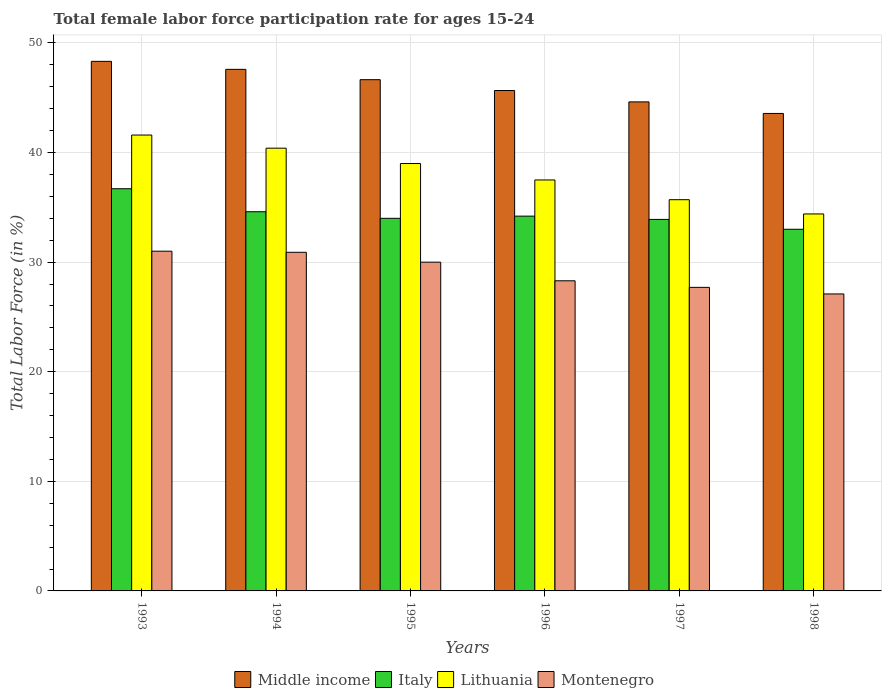How many bars are there on the 4th tick from the left?
Offer a terse response. 4. What is the label of the 4th group of bars from the left?
Give a very brief answer. 1996. In how many cases, is the number of bars for a given year not equal to the number of legend labels?
Ensure brevity in your answer.  0. What is the female labor force participation rate in Lithuania in 1994?
Offer a terse response. 40.4. Across all years, what is the maximum female labor force participation rate in Italy?
Give a very brief answer. 36.7. Across all years, what is the minimum female labor force participation rate in Italy?
Your response must be concise. 33. What is the total female labor force participation rate in Montenegro in the graph?
Your response must be concise. 175. What is the difference between the female labor force participation rate in Middle income in 1993 and that in 1997?
Your answer should be compact. 3.7. What is the average female labor force participation rate in Italy per year?
Your answer should be very brief. 34.4. In the year 1995, what is the difference between the female labor force participation rate in Lithuania and female labor force participation rate in Montenegro?
Offer a terse response. 9. What is the ratio of the female labor force participation rate in Lithuania in 1994 to that in 1995?
Make the answer very short. 1.04. Is the female labor force participation rate in Lithuania in 1994 less than that in 1997?
Your response must be concise. No. Is the difference between the female labor force participation rate in Lithuania in 1997 and 1998 greater than the difference between the female labor force participation rate in Montenegro in 1997 and 1998?
Provide a succinct answer. Yes. What is the difference between the highest and the second highest female labor force participation rate in Italy?
Your answer should be compact. 2.1. What is the difference between the highest and the lowest female labor force participation rate in Lithuania?
Provide a succinct answer. 7.2. In how many years, is the female labor force participation rate in Middle income greater than the average female labor force participation rate in Middle income taken over all years?
Offer a terse response. 3. Is it the case that in every year, the sum of the female labor force participation rate in Montenegro and female labor force participation rate in Middle income is greater than the sum of female labor force participation rate in Italy and female labor force participation rate in Lithuania?
Offer a terse response. Yes. What does the 3rd bar from the left in 1994 represents?
Your answer should be compact. Lithuania. What does the 4th bar from the right in 1998 represents?
Your response must be concise. Middle income. What is the title of the graph?
Keep it short and to the point. Total female labor force participation rate for ages 15-24. What is the Total Labor Force (in %) of Middle income in 1993?
Ensure brevity in your answer.  48.32. What is the Total Labor Force (in %) in Italy in 1993?
Provide a short and direct response. 36.7. What is the Total Labor Force (in %) of Lithuania in 1993?
Provide a short and direct response. 41.6. What is the Total Labor Force (in %) of Middle income in 1994?
Offer a very short reply. 47.59. What is the Total Labor Force (in %) in Italy in 1994?
Ensure brevity in your answer.  34.6. What is the Total Labor Force (in %) of Lithuania in 1994?
Offer a very short reply. 40.4. What is the Total Labor Force (in %) in Montenegro in 1994?
Make the answer very short. 30.9. What is the Total Labor Force (in %) in Middle income in 1995?
Offer a terse response. 46.65. What is the Total Labor Force (in %) of Montenegro in 1995?
Provide a succinct answer. 30. What is the Total Labor Force (in %) in Middle income in 1996?
Offer a terse response. 45.66. What is the Total Labor Force (in %) in Italy in 1996?
Give a very brief answer. 34.2. What is the Total Labor Force (in %) of Lithuania in 1996?
Offer a terse response. 37.5. What is the Total Labor Force (in %) of Montenegro in 1996?
Ensure brevity in your answer.  28.3. What is the Total Labor Force (in %) of Middle income in 1997?
Give a very brief answer. 44.62. What is the Total Labor Force (in %) of Italy in 1997?
Offer a terse response. 33.9. What is the Total Labor Force (in %) in Lithuania in 1997?
Keep it short and to the point. 35.7. What is the Total Labor Force (in %) in Montenegro in 1997?
Keep it short and to the point. 27.7. What is the Total Labor Force (in %) of Middle income in 1998?
Give a very brief answer. 43.57. What is the Total Labor Force (in %) of Lithuania in 1998?
Offer a terse response. 34.4. What is the Total Labor Force (in %) in Montenegro in 1998?
Your response must be concise. 27.1. Across all years, what is the maximum Total Labor Force (in %) in Middle income?
Make the answer very short. 48.32. Across all years, what is the maximum Total Labor Force (in %) in Italy?
Your answer should be very brief. 36.7. Across all years, what is the maximum Total Labor Force (in %) of Lithuania?
Your answer should be very brief. 41.6. Across all years, what is the maximum Total Labor Force (in %) of Montenegro?
Your answer should be very brief. 31. Across all years, what is the minimum Total Labor Force (in %) in Middle income?
Provide a succinct answer. 43.57. Across all years, what is the minimum Total Labor Force (in %) in Italy?
Ensure brevity in your answer.  33. Across all years, what is the minimum Total Labor Force (in %) of Lithuania?
Your answer should be compact. 34.4. Across all years, what is the minimum Total Labor Force (in %) in Montenegro?
Provide a succinct answer. 27.1. What is the total Total Labor Force (in %) of Middle income in the graph?
Provide a succinct answer. 276.42. What is the total Total Labor Force (in %) of Italy in the graph?
Your response must be concise. 206.4. What is the total Total Labor Force (in %) of Lithuania in the graph?
Provide a succinct answer. 228.6. What is the total Total Labor Force (in %) of Montenegro in the graph?
Your answer should be compact. 175. What is the difference between the Total Labor Force (in %) in Middle income in 1993 and that in 1994?
Provide a short and direct response. 0.73. What is the difference between the Total Labor Force (in %) in Italy in 1993 and that in 1994?
Offer a very short reply. 2.1. What is the difference between the Total Labor Force (in %) in Montenegro in 1993 and that in 1994?
Give a very brief answer. 0.1. What is the difference between the Total Labor Force (in %) of Middle income in 1993 and that in 1995?
Provide a short and direct response. 1.67. What is the difference between the Total Labor Force (in %) of Middle income in 1993 and that in 1996?
Provide a succinct answer. 2.66. What is the difference between the Total Labor Force (in %) in Italy in 1993 and that in 1996?
Make the answer very short. 2.5. What is the difference between the Total Labor Force (in %) in Lithuania in 1993 and that in 1996?
Offer a terse response. 4.1. What is the difference between the Total Labor Force (in %) in Montenegro in 1993 and that in 1996?
Offer a very short reply. 2.7. What is the difference between the Total Labor Force (in %) of Middle income in 1993 and that in 1997?
Your answer should be very brief. 3.7. What is the difference between the Total Labor Force (in %) of Italy in 1993 and that in 1997?
Keep it short and to the point. 2.8. What is the difference between the Total Labor Force (in %) of Middle income in 1993 and that in 1998?
Provide a short and direct response. 4.75. What is the difference between the Total Labor Force (in %) of Lithuania in 1993 and that in 1998?
Give a very brief answer. 7.2. What is the difference between the Total Labor Force (in %) in Middle income in 1994 and that in 1995?
Keep it short and to the point. 0.94. What is the difference between the Total Labor Force (in %) in Montenegro in 1994 and that in 1995?
Provide a short and direct response. 0.9. What is the difference between the Total Labor Force (in %) in Middle income in 1994 and that in 1996?
Offer a terse response. 1.93. What is the difference between the Total Labor Force (in %) in Italy in 1994 and that in 1996?
Make the answer very short. 0.4. What is the difference between the Total Labor Force (in %) in Lithuania in 1994 and that in 1996?
Your answer should be very brief. 2.9. What is the difference between the Total Labor Force (in %) of Middle income in 1994 and that in 1997?
Provide a succinct answer. 2.97. What is the difference between the Total Labor Force (in %) in Italy in 1994 and that in 1997?
Provide a short and direct response. 0.7. What is the difference between the Total Labor Force (in %) in Lithuania in 1994 and that in 1997?
Provide a short and direct response. 4.7. What is the difference between the Total Labor Force (in %) in Montenegro in 1994 and that in 1997?
Make the answer very short. 3.2. What is the difference between the Total Labor Force (in %) of Middle income in 1994 and that in 1998?
Your answer should be very brief. 4.02. What is the difference between the Total Labor Force (in %) in Italy in 1994 and that in 1998?
Offer a terse response. 1.6. What is the difference between the Total Labor Force (in %) of Lithuania in 1994 and that in 1998?
Ensure brevity in your answer.  6. What is the difference between the Total Labor Force (in %) of Middle income in 1995 and that in 1996?
Keep it short and to the point. 0.99. What is the difference between the Total Labor Force (in %) of Italy in 1995 and that in 1996?
Your response must be concise. -0.2. What is the difference between the Total Labor Force (in %) in Montenegro in 1995 and that in 1996?
Give a very brief answer. 1.7. What is the difference between the Total Labor Force (in %) in Middle income in 1995 and that in 1997?
Your response must be concise. 2.03. What is the difference between the Total Labor Force (in %) of Montenegro in 1995 and that in 1997?
Your answer should be compact. 2.3. What is the difference between the Total Labor Force (in %) of Middle income in 1995 and that in 1998?
Your response must be concise. 3.08. What is the difference between the Total Labor Force (in %) in Italy in 1995 and that in 1998?
Provide a succinct answer. 1. What is the difference between the Total Labor Force (in %) in Middle income in 1996 and that in 1997?
Ensure brevity in your answer.  1.04. What is the difference between the Total Labor Force (in %) of Italy in 1996 and that in 1997?
Ensure brevity in your answer.  0.3. What is the difference between the Total Labor Force (in %) of Lithuania in 1996 and that in 1997?
Keep it short and to the point. 1.8. What is the difference between the Total Labor Force (in %) of Montenegro in 1996 and that in 1997?
Provide a short and direct response. 0.6. What is the difference between the Total Labor Force (in %) in Middle income in 1996 and that in 1998?
Provide a succinct answer. 2.09. What is the difference between the Total Labor Force (in %) of Lithuania in 1996 and that in 1998?
Your answer should be compact. 3.1. What is the difference between the Total Labor Force (in %) of Montenegro in 1996 and that in 1998?
Keep it short and to the point. 1.2. What is the difference between the Total Labor Force (in %) in Middle income in 1997 and that in 1998?
Your response must be concise. 1.05. What is the difference between the Total Labor Force (in %) in Italy in 1997 and that in 1998?
Provide a succinct answer. 0.9. What is the difference between the Total Labor Force (in %) in Lithuania in 1997 and that in 1998?
Offer a very short reply. 1.3. What is the difference between the Total Labor Force (in %) of Middle income in 1993 and the Total Labor Force (in %) of Italy in 1994?
Make the answer very short. 13.72. What is the difference between the Total Labor Force (in %) in Middle income in 1993 and the Total Labor Force (in %) in Lithuania in 1994?
Give a very brief answer. 7.92. What is the difference between the Total Labor Force (in %) of Middle income in 1993 and the Total Labor Force (in %) of Montenegro in 1994?
Provide a short and direct response. 17.42. What is the difference between the Total Labor Force (in %) in Italy in 1993 and the Total Labor Force (in %) in Lithuania in 1994?
Offer a terse response. -3.7. What is the difference between the Total Labor Force (in %) in Middle income in 1993 and the Total Labor Force (in %) in Italy in 1995?
Provide a short and direct response. 14.32. What is the difference between the Total Labor Force (in %) of Middle income in 1993 and the Total Labor Force (in %) of Lithuania in 1995?
Ensure brevity in your answer.  9.32. What is the difference between the Total Labor Force (in %) in Middle income in 1993 and the Total Labor Force (in %) in Montenegro in 1995?
Provide a succinct answer. 18.32. What is the difference between the Total Labor Force (in %) in Italy in 1993 and the Total Labor Force (in %) in Montenegro in 1995?
Your answer should be very brief. 6.7. What is the difference between the Total Labor Force (in %) in Lithuania in 1993 and the Total Labor Force (in %) in Montenegro in 1995?
Provide a short and direct response. 11.6. What is the difference between the Total Labor Force (in %) of Middle income in 1993 and the Total Labor Force (in %) of Italy in 1996?
Ensure brevity in your answer.  14.12. What is the difference between the Total Labor Force (in %) in Middle income in 1993 and the Total Labor Force (in %) in Lithuania in 1996?
Provide a succinct answer. 10.82. What is the difference between the Total Labor Force (in %) of Middle income in 1993 and the Total Labor Force (in %) of Montenegro in 1996?
Your response must be concise. 20.02. What is the difference between the Total Labor Force (in %) in Lithuania in 1993 and the Total Labor Force (in %) in Montenegro in 1996?
Give a very brief answer. 13.3. What is the difference between the Total Labor Force (in %) in Middle income in 1993 and the Total Labor Force (in %) in Italy in 1997?
Your response must be concise. 14.42. What is the difference between the Total Labor Force (in %) in Middle income in 1993 and the Total Labor Force (in %) in Lithuania in 1997?
Your answer should be very brief. 12.62. What is the difference between the Total Labor Force (in %) of Middle income in 1993 and the Total Labor Force (in %) of Montenegro in 1997?
Your answer should be compact. 20.62. What is the difference between the Total Labor Force (in %) in Middle income in 1993 and the Total Labor Force (in %) in Italy in 1998?
Offer a very short reply. 15.32. What is the difference between the Total Labor Force (in %) in Middle income in 1993 and the Total Labor Force (in %) in Lithuania in 1998?
Your answer should be very brief. 13.92. What is the difference between the Total Labor Force (in %) of Middle income in 1993 and the Total Labor Force (in %) of Montenegro in 1998?
Offer a very short reply. 21.22. What is the difference between the Total Labor Force (in %) in Italy in 1993 and the Total Labor Force (in %) in Lithuania in 1998?
Keep it short and to the point. 2.3. What is the difference between the Total Labor Force (in %) in Italy in 1993 and the Total Labor Force (in %) in Montenegro in 1998?
Ensure brevity in your answer.  9.6. What is the difference between the Total Labor Force (in %) of Lithuania in 1993 and the Total Labor Force (in %) of Montenegro in 1998?
Provide a succinct answer. 14.5. What is the difference between the Total Labor Force (in %) of Middle income in 1994 and the Total Labor Force (in %) of Italy in 1995?
Provide a succinct answer. 13.59. What is the difference between the Total Labor Force (in %) of Middle income in 1994 and the Total Labor Force (in %) of Lithuania in 1995?
Your response must be concise. 8.59. What is the difference between the Total Labor Force (in %) in Middle income in 1994 and the Total Labor Force (in %) in Montenegro in 1995?
Make the answer very short. 17.59. What is the difference between the Total Labor Force (in %) in Middle income in 1994 and the Total Labor Force (in %) in Italy in 1996?
Make the answer very short. 13.39. What is the difference between the Total Labor Force (in %) of Middle income in 1994 and the Total Labor Force (in %) of Lithuania in 1996?
Your response must be concise. 10.09. What is the difference between the Total Labor Force (in %) in Middle income in 1994 and the Total Labor Force (in %) in Montenegro in 1996?
Keep it short and to the point. 19.29. What is the difference between the Total Labor Force (in %) in Italy in 1994 and the Total Labor Force (in %) in Lithuania in 1996?
Offer a terse response. -2.9. What is the difference between the Total Labor Force (in %) of Italy in 1994 and the Total Labor Force (in %) of Montenegro in 1996?
Keep it short and to the point. 6.3. What is the difference between the Total Labor Force (in %) of Middle income in 1994 and the Total Labor Force (in %) of Italy in 1997?
Ensure brevity in your answer.  13.69. What is the difference between the Total Labor Force (in %) in Middle income in 1994 and the Total Labor Force (in %) in Lithuania in 1997?
Your answer should be very brief. 11.89. What is the difference between the Total Labor Force (in %) of Middle income in 1994 and the Total Labor Force (in %) of Montenegro in 1997?
Your answer should be compact. 19.89. What is the difference between the Total Labor Force (in %) in Italy in 1994 and the Total Labor Force (in %) in Montenegro in 1997?
Offer a terse response. 6.9. What is the difference between the Total Labor Force (in %) in Middle income in 1994 and the Total Labor Force (in %) in Italy in 1998?
Offer a very short reply. 14.59. What is the difference between the Total Labor Force (in %) in Middle income in 1994 and the Total Labor Force (in %) in Lithuania in 1998?
Your response must be concise. 13.19. What is the difference between the Total Labor Force (in %) in Middle income in 1994 and the Total Labor Force (in %) in Montenegro in 1998?
Your response must be concise. 20.49. What is the difference between the Total Labor Force (in %) in Italy in 1994 and the Total Labor Force (in %) in Montenegro in 1998?
Offer a very short reply. 7.5. What is the difference between the Total Labor Force (in %) in Lithuania in 1994 and the Total Labor Force (in %) in Montenegro in 1998?
Your response must be concise. 13.3. What is the difference between the Total Labor Force (in %) of Middle income in 1995 and the Total Labor Force (in %) of Italy in 1996?
Offer a very short reply. 12.45. What is the difference between the Total Labor Force (in %) in Middle income in 1995 and the Total Labor Force (in %) in Lithuania in 1996?
Your response must be concise. 9.15. What is the difference between the Total Labor Force (in %) in Middle income in 1995 and the Total Labor Force (in %) in Montenegro in 1996?
Your answer should be very brief. 18.35. What is the difference between the Total Labor Force (in %) of Lithuania in 1995 and the Total Labor Force (in %) of Montenegro in 1996?
Offer a very short reply. 10.7. What is the difference between the Total Labor Force (in %) of Middle income in 1995 and the Total Labor Force (in %) of Italy in 1997?
Ensure brevity in your answer.  12.75. What is the difference between the Total Labor Force (in %) of Middle income in 1995 and the Total Labor Force (in %) of Lithuania in 1997?
Give a very brief answer. 10.95. What is the difference between the Total Labor Force (in %) of Middle income in 1995 and the Total Labor Force (in %) of Montenegro in 1997?
Keep it short and to the point. 18.95. What is the difference between the Total Labor Force (in %) of Italy in 1995 and the Total Labor Force (in %) of Montenegro in 1997?
Your response must be concise. 6.3. What is the difference between the Total Labor Force (in %) in Lithuania in 1995 and the Total Labor Force (in %) in Montenegro in 1997?
Your answer should be very brief. 11.3. What is the difference between the Total Labor Force (in %) in Middle income in 1995 and the Total Labor Force (in %) in Italy in 1998?
Your answer should be compact. 13.65. What is the difference between the Total Labor Force (in %) in Middle income in 1995 and the Total Labor Force (in %) in Lithuania in 1998?
Offer a terse response. 12.25. What is the difference between the Total Labor Force (in %) of Middle income in 1995 and the Total Labor Force (in %) of Montenegro in 1998?
Give a very brief answer. 19.55. What is the difference between the Total Labor Force (in %) in Italy in 1995 and the Total Labor Force (in %) in Montenegro in 1998?
Give a very brief answer. 6.9. What is the difference between the Total Labor Force (in %) of Middle income in 1996 and the Total Labor Force (in %) of Italy in 1997?
Your answer should be very brief. 11.76. What is the difference between the Total Labor Force (in %) in Middle income in 1996 and the Total Labor Force (in %) in Lithuania in 1997?
Your answer should be compact. 9.96. What is the difference between the Total Labor Force (in %) of Middle income in 1996 and the Total Labor Force (in %) of Montenegro in 1997?
Ensure brevity in your answer.  17.96. What is the difference between the Total Labor Force (in %) in Italy in 1996 and the Total Labor Force (in %) in Lithuania in 1997?
Your answer should be very brief. -1.5. What is the difference between the Total Labor Force (in %) in Middle income in 1996 and the Total Labor Force (in %) in Italy in 1998?
Keep it short and to the point. 12.66. What is the difference between the Total Labor Force (in %) of Middle income in 1996 and the Total Labor Force (in %) of Lithuania in 1998?
Your answer should be very brief. 11.26. What is the difference between the Total Labor Force (in %) of Middle income in 1996 and the Total Labor Force (in %) of Montenegro in 1998?
Provide a short and direct response. 18.56. What is the difference between the Total Labor Force (in %) of Italy in 1996 and the Total Labor Force (in %) of Lithuania in 1998?
Provide a short and direct response. -0.2. What is the difference between the Total Labor Force (in %) of Italy in 1996 and the Total Labor Force (in %) of Montenegro in 1998?
Your answer should be compact. 7.1. What is the difference between the Total Labor Force (in %) in Lithuania in 1996 and the Total Labor Force (in %) in Montenegro in 1998?
Your answer should be very brief. 10.4. What is the difference between the Total Labor Force (in %) in Middle income in 1997 and the Total Labor Force (in %) in Italy in 1998?
Your response must be concise. 11.62. What is the difference between the Total Labor Force (in %) in Middle income in 1997 and the Total Labor Force (in %) in Lithuania in 1998?
Give a very brief answer. 10.22. What is the difference between the Total Labor Force (in %) in Middle income in 1997 and the Total Labor Force (in %) in Montenegro in 1998?
Provide a short and direct response. 17.52. What is the difference between the Total Labor Force (in %) in Italy in 1997 and the Total Labor Force (in %) in Montenegro in 1998?
Your answer should be very brief. 6.8. What is the difference between the Total Labor Force (in %) in Lithuania in 1997 and the Total Labor Force (in %) in Montenegro in 1998?
Keep it short and to the point. 8.6. What is the average Total Labor Force (in %) in Middle income per year?
Keep it short and to the point. 46.07. What is the average Total Labor Force (in %) of Italy per year?
Ensure brevity in your answer.  34.4. What is the average Total Labor Force (in %) of Lithuania per year?
Provide a succinct answer. 38.1. What is the average Total Labor Force (in %) of Montenegro per year?
Ensure brevity in your answer.  29.17. In the year 1993, what is the difference between the Total Labor Force (in %) of Middle income and Total Labor Force (in %) of Italy?
Make the answer very short. 11.62. In the year 1993, what is the difference between the Total Labor Force (in %) of Middle income and Total Labor Force (in %) of Lithuania?
Keep it short and to the point. 6.72. In the year 1993, what is the difference between the Total Labor Force (in %) in Middle income and Total Labor Force (in %) in Montenegro?
Provide a short and direct response. 17.32. In the year 1993, what is the difference between the Total Labor Force (in %) of Italy and Total Labor Force (in %) of Lithuania?
Offer a terse response. -4.9. In the year 1994, what is the difference between the Total Labor Force (in %) of Middle income and Total Labor Force (in %) of Italy?
Your answer should be very brief. 12.99. In the year 1994, what is the difference between the Total Labor Force (in %) of Middle income and Total Labor Force (in %) of Lithuania?
Provide a succinct answer. 7.19. In the year 1994, what is the difference between the Total Labor Force (in %) of Middle income and Total Labor Force (in %) of Montenegro?
Ensure brevity in your answer.  16.69. In the year 1994, what is the difference between the Total Labor Force (in %) in Italy and Total Labor Force (in %) in Lithuania?
Provide a succinct answer. -5.8. In the year 1994, what is the difference between the Total Labor Force (in %) of Lithuania and Total Labor Force (in %) of Montenegro?
Your answer should be very brief. 9.5. In the year 1995, what is the difference between the Total Labor Force (in %) in Middle income and Total Labor Force (in %) in Italy?
Give a very brief answer. 12.65. In the year 1995, what is the difference between the Total Labor Force (in %) in Middle income and Total Labor Force (in %) in Lithuania?
Give a very brief answer. 7.65. In the year 1995, what is the difference between the Total Labor Force (in %) in Middle income and Total Labor Force (in %) in Montenegro?
Give a very brief answer. 16.65. In the year 1995, what is the difference between the Total Labor Force (in %) in Lithuania and Total Labor Force (in %) in Montenegro?
Provide a succinct answer. 9. In the year 1996, what is the difference between the Total Labor Force (in %) in Middle income and Total Labor Force (in %) in Italy?
Provide a short and direct response. 11.46. In the year 1996, what is the difference between the Total Labor Force (in %) in Middle income and Total Labor Force (in %) in Lithuania?
Keep it short and to the point. 8.16. In the year 1996, what is the difference between the Total Labor Force (in %) in Middle income and Total Labor Force (in %) in Montenegro?
Provide a succinct answer. 17.36. In the year 1996, what is the difference between the Total Labor Force (in %) in Italy and Total Labor Force (in %) in Montenegro?
Your answer should be very brief. 5.9. In the year 1996, what is the difference between the Total Labor Force (in %) in Lithuania and Total Labor Force (in %) in Montenegro?
Provide a short and direct response. 9.2. In the year 1997, what is the difference between the Total Labor Force (in %) in Middle income and Total Labor Force (in %) in Italy?
Keep it short and to the point. 10.72. In the year 1997, what is the difference between the Total Labor Force (in %) of Middle income and Total Labor Force (in %) of Lithuania?
Ensure brevity in your answer.  8.92. In the year 1997, what is the difference between the Total Labor Force (in %) in Middle income and Total Labor Force (in %) in Montenegro?
Offer a very short reply. 16.92. In the year 1997, what is the difference between the Total Labor Force (in %) of Italy and Total Labor Force (in %) of Lithuania?
Ensure brevity in your answer.  -1.8. In the year 1997, what is the difference between the Total Labor Force (in %) in Italy and Total Labor Force (in %) in Montenegro?
Ensure brevity in your answer.  6.2. In the year 1998, what is the difference between the Total Labor Force (in %) in Middle income and Total Labor Force (in %) in Italy?
Provide a short and direct response. 10.57. In the year 1998, what is the difference between the Total Labor Force (in %) in Middle income and Total Labor Force (in %) in Lithuania?
Your response must be concise. 9.17. In the year 1998, what is the difference between the Total Labor Force (in %) of Middle income and Total Labor Force (in %) of Montenegro?
Make the answer very short. 16.47. In the year 1998, what is the difference between the Total Labor Force (in %) in Italy and Total Labor Force (in %) in Lithuania?
Your answer should be compact. -1.4. In the year 1998, what is the difference between the Total Labor Force (in %) of Italy and Total Labor Force (in %) of Montenegro?
Give a very brief answer. 5.9. What is the ratio of the Total Labor Force (in %) in Middle income in 1993 to that in 1994?
Provide a succinct answer. 1.02. What is the ratio of the Total Labor Force (in %) in Italy in 1993 to that in 1994?
Make the answer very short. 1.06. What is the ratio of the Total Labor Force (in %) in Lithuania in 1993 to that in 1994?
Give a very brief answer. 1.03. What is the ratio of the Total Labor Force (in %) of Middle income in 1993 to that in 1995?
Your answer should be very brief. 1.04. What is the ratio of the Total Labor Force (in %) of Italy in 1993 to that in 1995?
Give a very brief answer. 1.08. What is the ratio of the Total Labor Force (in %) in Lithuania in 1993 to that in 1995?
Provide a succinct answer. 1.07. What is the ratio of the Total Labor Force (in %) in Montenegro in 1993 to that in 1995?
Keep it short and to the point. 1.03. What is the ratio of the Total Labor Force (in %) of Middle income in 1993 to that in 1996?
Give a very brief answer. 1.06. What is the ratio of the Total Labor Force (in %) in Italy in 1993 to that in 1996?
Make the answer very short. 1.07. What is the ratio of the Total Labor Force (in %) in Lithuania in 1993 to that in 1996?
Your answer should be compact. 1.11. What is the ratio of the Total Labor Force (in %) of Montenegro in 1993 to that in 1996?
Offer a terse response. 1.1. What is the ratio of the Total Labor Force (in %) of Middle income in 1993 to that in 1997?
Ensure brevity in your answer.  1.08. What is the ratio of the Total Labor Force (in %) of Italy in 1993 to that in 1997?
Your response must be concise. 1.08. What is the ratio of the Total Labor Force (in %) of Lithuania in 1993 to that in 1997?
Make the answer very short. 1.17. What is the ratio of the Total Labor Force (in %) in Montenegro in 1993 to that in 1997?
Your answer should be very brief. 1.12. What is the ratio of the Total Labor Force (in %) of Middle income in 1993 to that in 1998?
Make the answer very short. 1.11. What is the ratio of the Total Labor Force (in %) in Italy in 1993 to that in 1998?
Make the answer very short. 1.11. What is the ratio of the Total Labor Force (in %) of Lithuania in 1993 to that in 1998?
Your answer should be compact. 1.21. What is the ratio of the Total Labor Force (in %) in Montenegro in 1993 to that in 1998?
Ensure brevity in your answer.  1.14. What is the ratio of the Total Labor Force (in %) in Middle income in 1994 to that in 1995?
Provide a short and direct response. 1.02. What is the ratio of the Total Labor Force (in %) of Italy in 1994 to that in 1995?
Your response must be concise. 1.02. What is the ratio of the Total Labor Force (in %) of Lithuania in 1994 to that in 1995?
Offer a terse response. 1.04. What is the ratio of the Total Labor Force (in %) in Montenegro in 1994 to that in 1995?
Your answer should be very brief. 1.03. What is the ratio of the Total Labor Force (in %) in Middle income in 1994 to that in 1996?
Your answer should be compact. 1.04. What is the ratio of the Total Labor Force (in %) of Italy in 1994 to that in 1996?
Provide a succinct answer. 1.01. What is the ratio of the Total Labor Force (in %) of Lithuania in 1994 to that in 1996?
Give a very brief answer. 1.08. What is the ratio of the Total Labor Force (in %) of Montenegro in 1994 to that in 1996?
Keep it short and to the point. 1.09. What is the ratio of the Total Labor Force (in %) in Middle income in 1994 to that in 1997?
Offer a very short reply. 1.07. What is the ratio of the Total Labor Force (in %) in Italy in 1994 to that in 1997?
Ensure brevity in your answer.  1.02. What is the ratio of the Total Labor Force (in %) of Lithuania in 1994 to that in 1997?
Provide a succinct answer. 1.13. What is the ratio of the Total Labor Force (in %) in Montenegro in 1994 to that in 1997?
Keep it short and to the point. 1.12. What is the ratio of the Total Labor Force (in %) in Middle income in 1994 to that in 1998?
Offer a very short reply. 1.09. What is the ratio of the Total Labor Force (in %) of Italy in 1994 to that in 1998?
Your response must be concise. 1.05. What is the ratio of the Total Labor Force (in %) of Lithuania in 1994 to that in 1998?
Keep it short and to the point. 1.17. What is the ratio of the Total Labor Force (in %) of Montenegro in 1994 to that in 1998?
Offer a terse response. 1.14. What is the ratio of the Total Labor Force (in %) of Middle income in 1995 to that in 1996?
Your response must be concise. 1.02. What is the ratio of the Total Labor Force (in %) of Lithuania in 1995 to that in 1996?
Your response must be concise. 1.04. What is the ratio of the Total Labor Force (in %) in Montenegro in 1995 to that in 1996?
Provide a short and direct response. 1.06. What is the ratio of the Total Labor Force (in %) of Middle income in 1995 to that in 1997?
Give a very brief answer. 1.05. What is the ratio of the Total Labor Force (in %) of Lithuania in 1995 to that in 1997?
Your response must be concise. 1.09. What is the ratio of the Total Labor Force (in %) of Montenegro in 1995 to that in 1997?
Ensure brevity in your answer.  1.08. What is the ratio of the Total Labor Force (in %) of Middle income in 1995 to that in 1998?
Offer a terse response. 1.07. What is the ratio of the Total Labor Force (in %) of Italy in 1995 to that in 1998?
Offer a very short reply. 1.03. What is the ratio of the Total Labor Force (in %) in Lithuania in 1995 to that in 1998?
Provide a succinct answer. 1.13. What is the ratio of the Total Labor Force (in %) of Montenegro in 1995 to that in 1998?
Offer a terse response. 1.11. What is the ratio of the Total Labor Force (in %) of Middle income in 1996 to that in 1997?
Provide a succinct answer. 1.02. What is the ratio of the Total Labor Force (in %) in Italy in 1996 to that in 1997?
Keep it short and to the point. 1.01. What is the ratio of the Total Labor Force (in %) in Lithuania in 1996 to that in 1997?
Keep it short and to the point. 1.05. What is the ratio of the Total Labor Force (in %) in Montenegro in 1996 to that in 1997?
Your answer should be very brief. 1.02. What is the ratio of the Total Labor Force (in %) in Middle income in 1996 to that in 1998?
Your answer should be compact. 1.05. What is the ratio of the Total Labor Force (in %) of Italy in 1996 to that in 1998?
Provide a short and direct response. 1.04. What is the ratio of the Total Labor Force (in %) in Lithuania in 1996 to that in 1998?
Provide a succinct answer. 1.09. What is the ratio of the Total Labor Force (in %) in Montenegro in 1996 to that in 1998?
Your answer should be compact. 1.04. What is the ratio of the Total Labor Force (in %) of Middle income in 1997 to that in 1998?
Your response must be concise. 1.02. What is the ratio of the Total Labor Force (in %) in Italy in 1997 to that in 1998?
Offer a very short reply. 1.03. What is the ratio of the Total Labor Force (in %) in Lithuania in 1997 to that in 1998?
Offer a very short reply. 1.04. What is the ratio of the Total Labor Force (in %) in Montenegro in 1997 to that in 1998?
Offer a very short reply. 1.02. What is the difference between the highest and the second highest Total Labor Force (in %) of Middle income?
Ensure brevity in your answer.  0.73. What is the difference between the highest and the second highest Total Labor Force (in %) in Lithuania?
Provide a succinct answer. 1.2. What is the difference between the highest and the second highest Total Labor Force (in %) in Montenegro?
Give a very brief answer. 0.1. What is the difference between the highest and the lowest Total Labor Force (in %) in Middle income?
Provide a succinct answer. 4.75. What is the difference between the highest and the lowest Total Labor Force (in %) of Montenegro?
Make the answer very short. 3.9. 